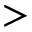Convert formula to latex. <formula><loc_0><loc_0><loc_500><loc_500>></formula> 